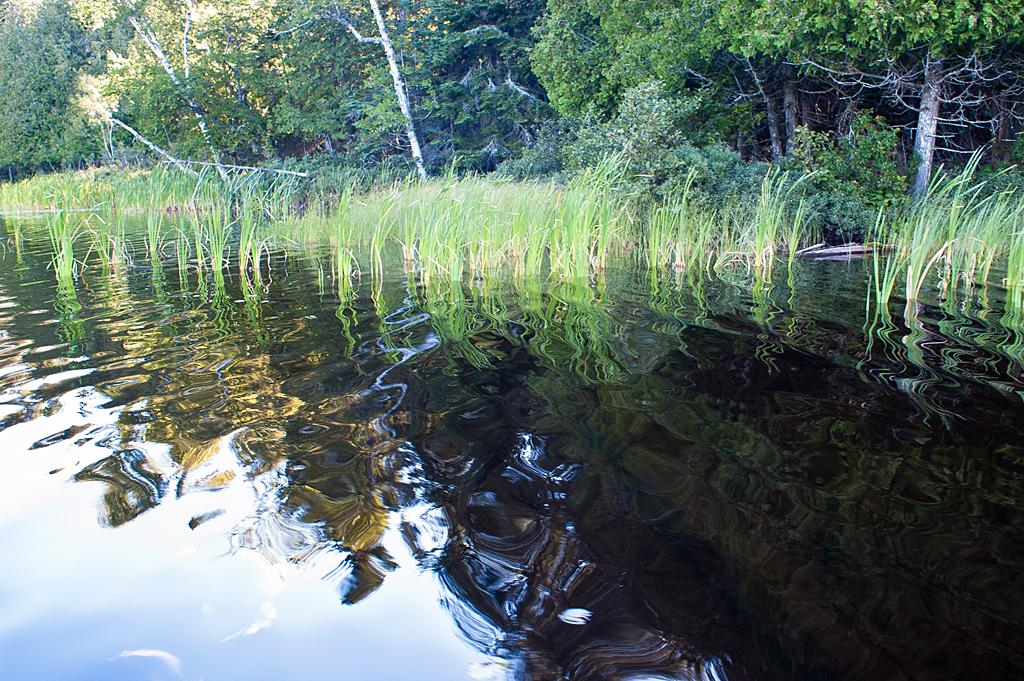What type of vegetation can be seen in the image? There are trees in the image. What is present at the bottom of the image? There is grass at the bottom of the image. What natural element is visible in the image? There is water visible in the image. What can be observed about the sky in the image? The sky is reflected on the water. What color is the bridge in the image? There is no bridge present in the image. How does the silver object interact with the trees in the image? There is no silver object present in the image. 